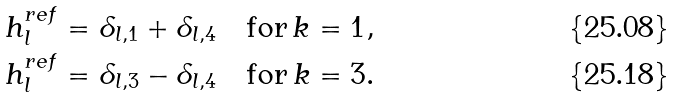<formula> <loc_0><loc_0><loc_500><loc_500>h ^ { r e f } _ { l } & = \delta _ { l , 1 } + \delta _ { l , 4 } \quad \text {for} \, k = 1 , \\ h ^ { r e f } _ { l } & = \delta _ { l , 3 } - \delta _ { l , 4 } \quad \text {for} \, k = 3 .</formula> 